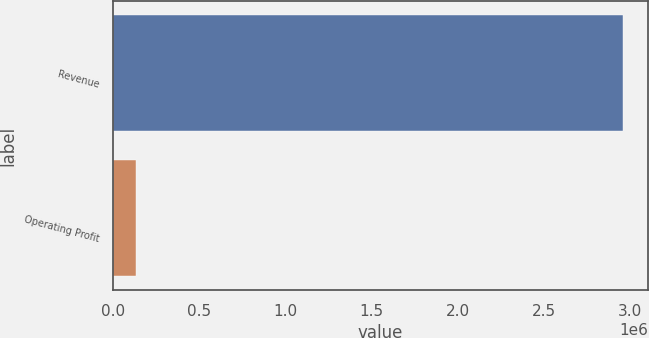<chart> <loc_0><loc_0><loc_500><loc_500><bar_chart><fcel>Revenue<fcel>Operating Profit<nl><fcel>2.95639e+06<fcel>134230<nl></chart> 